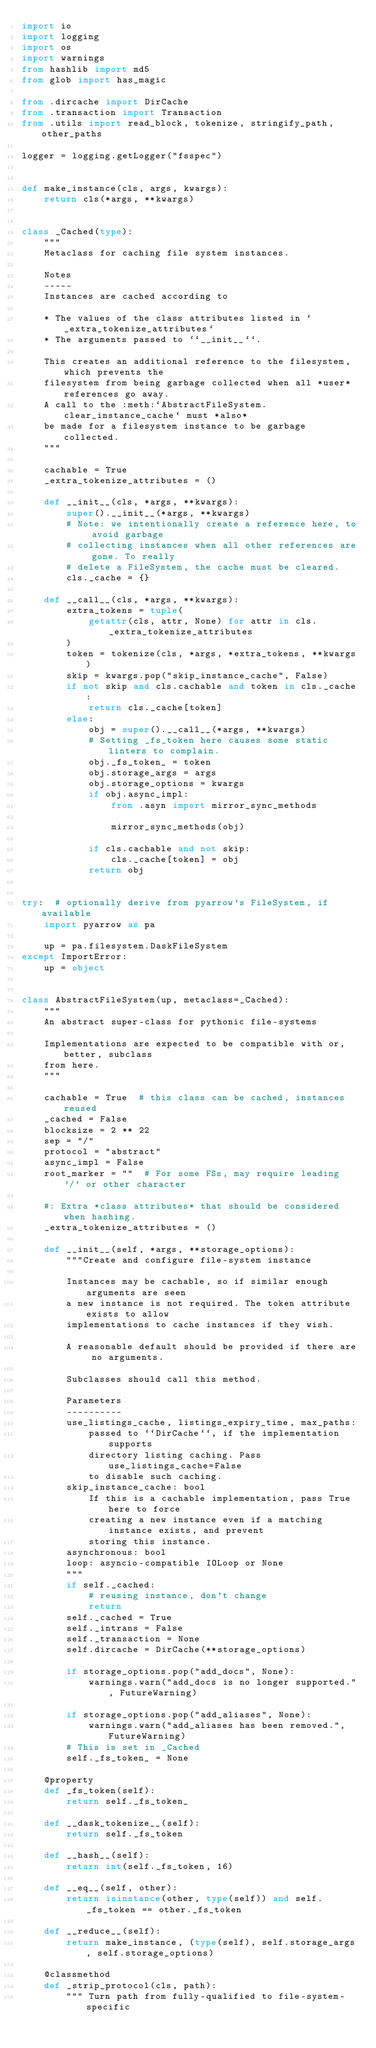Convert code to text. <code><loc_0><loc_0><loc_500><loc_500><_Python_>import io
import logging
import os
import warnings
from hashlib import md5
from glob import has_magic

from .dircache import DirCache
from .transaction import Transaction
from .utils import read_block, tokenize, stringify_path, other_paths

logger = logging.getLogger("fsspec")


def make_instance(cls, args, kwargs):
    return cls(*args, **kwargs)


class _Cached(type):
    """
    Metaclass for caching file system instances.

    Notes
    -----
    Instances are cached according to

    * The values of the class attributes listed in `_extra_tokenize_attributes`
    * The arguments passed to ``__init__``.

    This creates an additional reference to the filesystem, which prevents the
    filesystem from being garbage collected when all *user* references go away.
    A call to the :meth:`AbstractFileSystem.clear_instance_cache` must *also*
    be made for a filesystem instance to be garbage collected.
    """

    cachable = True
    _extra_tokenize_attributes = ()

    def __init__(cls, *args, **kwargs):
        super().__init__(*args, **kwargs)
        # Note: we intentionally create a reference here, to avoid garbage
        # collecting instances when all other references are gone. To really
        # delete a FileSystem, the cache must be cleared.
        cls._cache = {}

    def __call__(cls, *args, **kwargs):
        extra_tokens = tuple(
            getattr(cls, attr, None) for attr in cls._extra_tokenize_attributes
        )
        token = tokenize(cls, *args, *extra_tokens, **kwargs)
        skip = kwargs.pop("skip_instance_cache", False)
        if not skip and cls.cachable and token in cls._cache:
            return cls._cache[token]
        else:
            obj = super().__call__(*args, **kwargs)
            # Setting _fs_token here causes some static linters to complain.
            obj._fs_token_ = token
            obj.storage_args = args
            obj.storage_options = kwargs
            if obj.async_impl:
                from .asyn import mirror_sync_methods

                mirror_sync_methods(obj)

            if cls.cachable and not skip:
                cls._cache[token] = obj
            return obj


try:  # optionally derive from pyarrow's FileSystem, if available
    import pyarrow as pa

    up = pa.filesystem.DaskFileSystem
except ImportError:
    up = object


class AbstractFileSystem(up, metaclass=_Cached):
    """
    An abstract super-class for pythonic file-systems

    Implementations are expected to be compatible with or, better, subclass
    from here.
    """

    cachable = True  # this class can be cached, instances reused
    _cached = False
    blocksize = 2 ** 22
    sep = "/"
    protocol = "abstract"
    async_impl = False
    root_marker = ""  # For some FSs, may require leading '/' or other character

    #: Extra *class attributes* that should be considered when hashing.
    _extra_tokenize_attributes = ()

    def __init__(self, *args, **storage_options):
        """Create and configure file-system instance

        Instances may be cachable, so if similar enough arguments are seen
        a new instance is not required. The token attribute exists to allow
        implementations to cache instances if they wish.

        A reasonable default should be provided if there are no arguments.

        Subclasses should call this method.

        Parameters
        ----------
        use_listings_cache, listings_expiry_time, max_paths:
            passed to ``DirCache``, if the implementation supports
            directory listing caching. Pass use_listings_cache=False
            to disable such caching.
        skip_instance_cache: bool
            If this is a cachable implementation, pass True here to force
            creating a new instance even if a matching instance exists, and prevent
            storing this instance.
        asynchronous: bool
        loop: asyncio-compatible IOLoop or None
        """
        if self._cached:
            # reusing instance, don't change
            return
        self._cached = True
        self._intrans = False
        self._transaction = None
        self.dircache = DirCache(**storage_options)

        if storage_options.pop("add_docs", None):
            warnings.warn("add_docs is no longer supported.", FutureWarning)

        if storage_options.pop("add_aliases", None):
            warnings.warn("add_aliases has been removed.", FutureWarning)
        # This is set in _Cached
        self._fs_token_ = None

    @property
    def _fs_token(self):
        return self._fs_token_

    def __dask_tokenize__(self):
        return self._fs_token

    def __hash__(self):
        return int(self._fs_token, 16)

    def __eq__(self, other):
        return isinstance(other, type(self)) and self._fs_token == other._fs_token

    def __reduce__(self):
        return make_instance, (type(self), self.storage_args, self.storage_options)

    @classmethod
    def _strip_protocol(cls, path):
        """ Turn path from fully-qualified to file-system-specific
</code> 